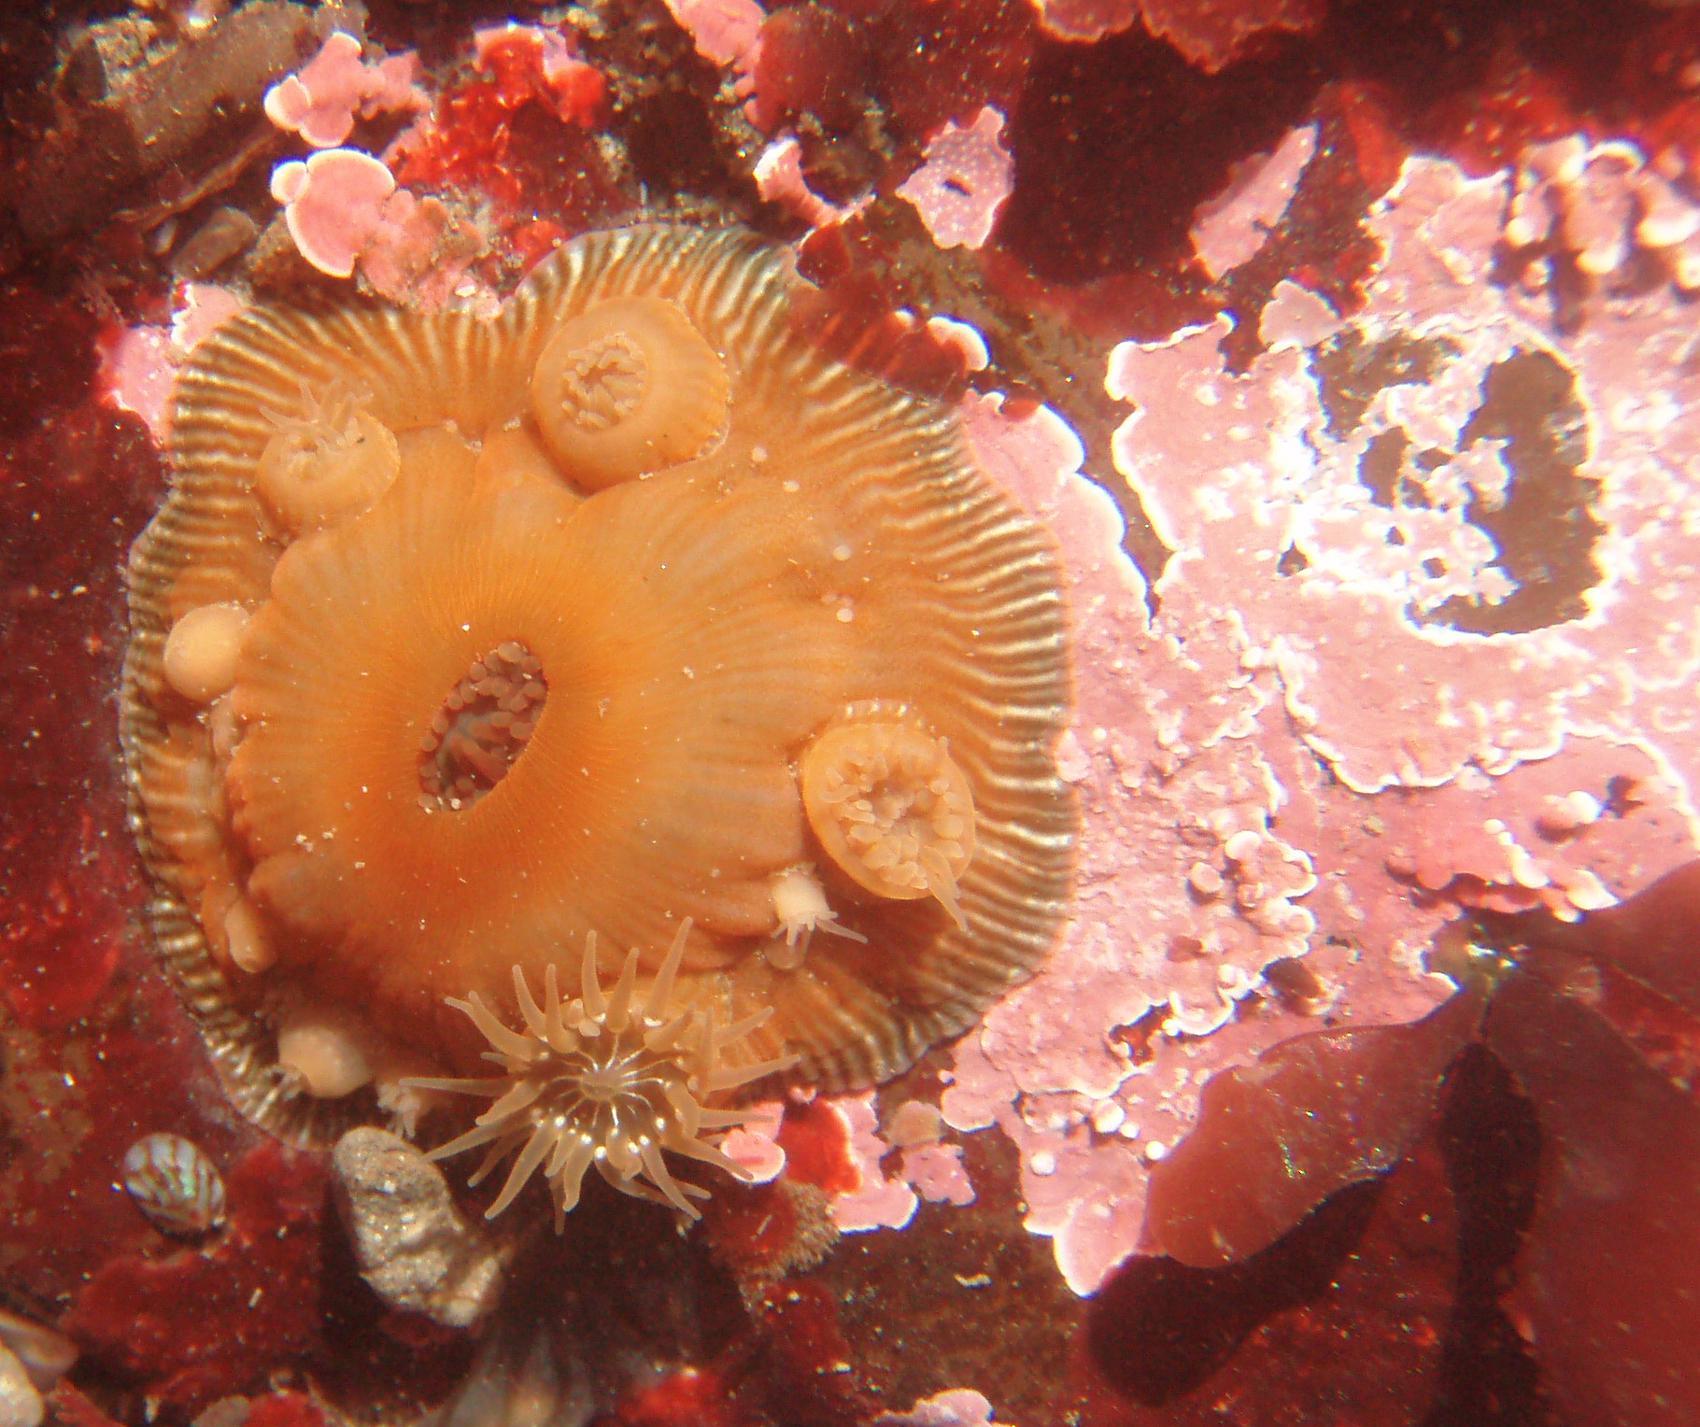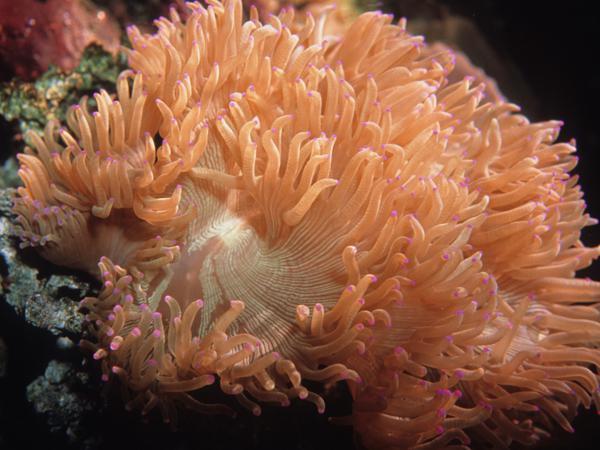The first image is the image on the left, the second image is the image on the right. For the images displayed, is the sentence "At least one of the images shows more than one anemone." factually correct? Answer yes or no. No. The first image is the image on the left, the second image is the image on the right. For the images shown, is this caption "The base of the anemone is red in the image on the right." true? Answer yes or no. No. 